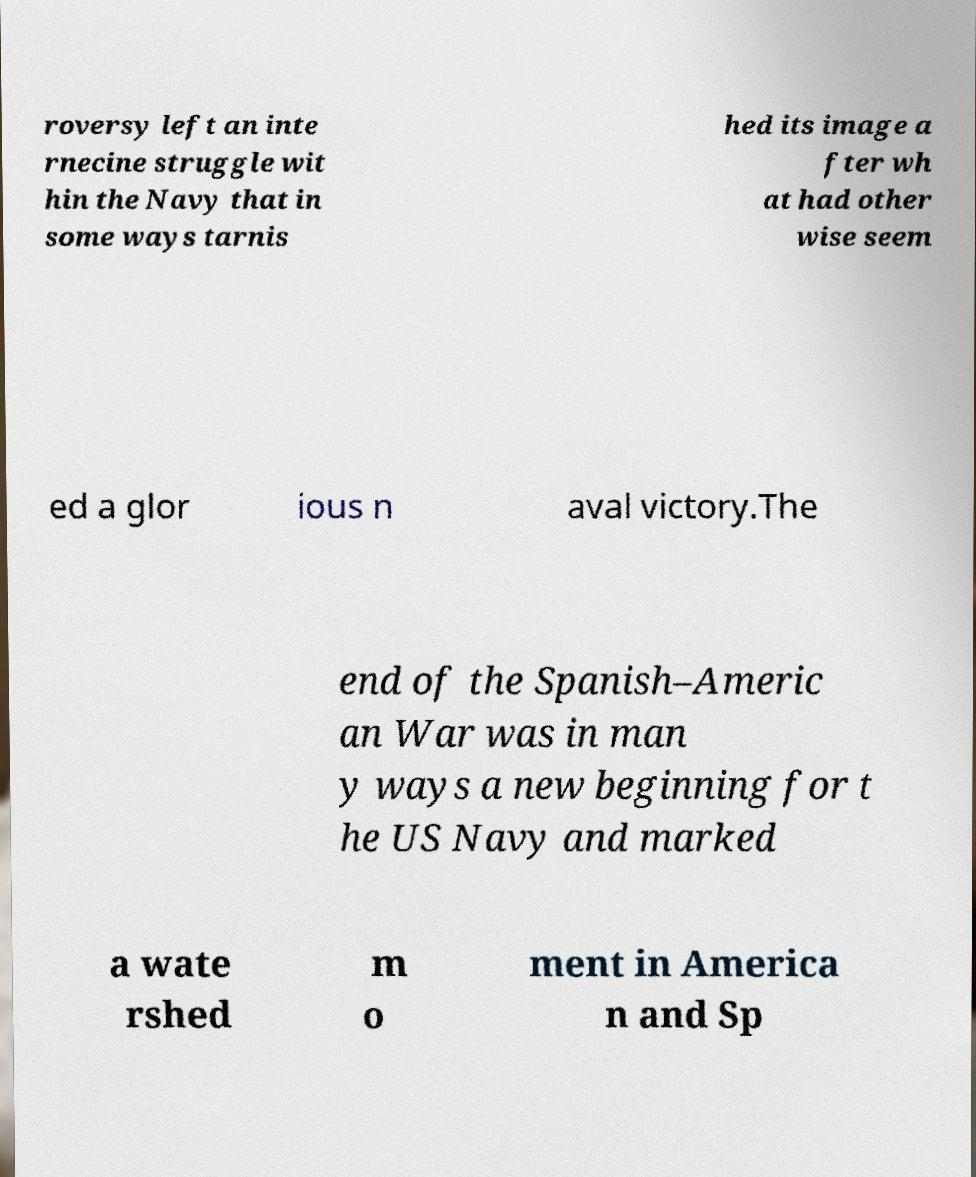Can you accurately transcribe the text from the provided image for me? roversy left an inte rnecine struggle wit hin the Navy that in some ways tarnis hed its image a fter wh at had other wise seem ed a glor ious n aval victory.The end of the Spanish–Americ an War was in man y ways a new beginning for t he US Navy and marked a wate rshed m o ment in America n and Sp 